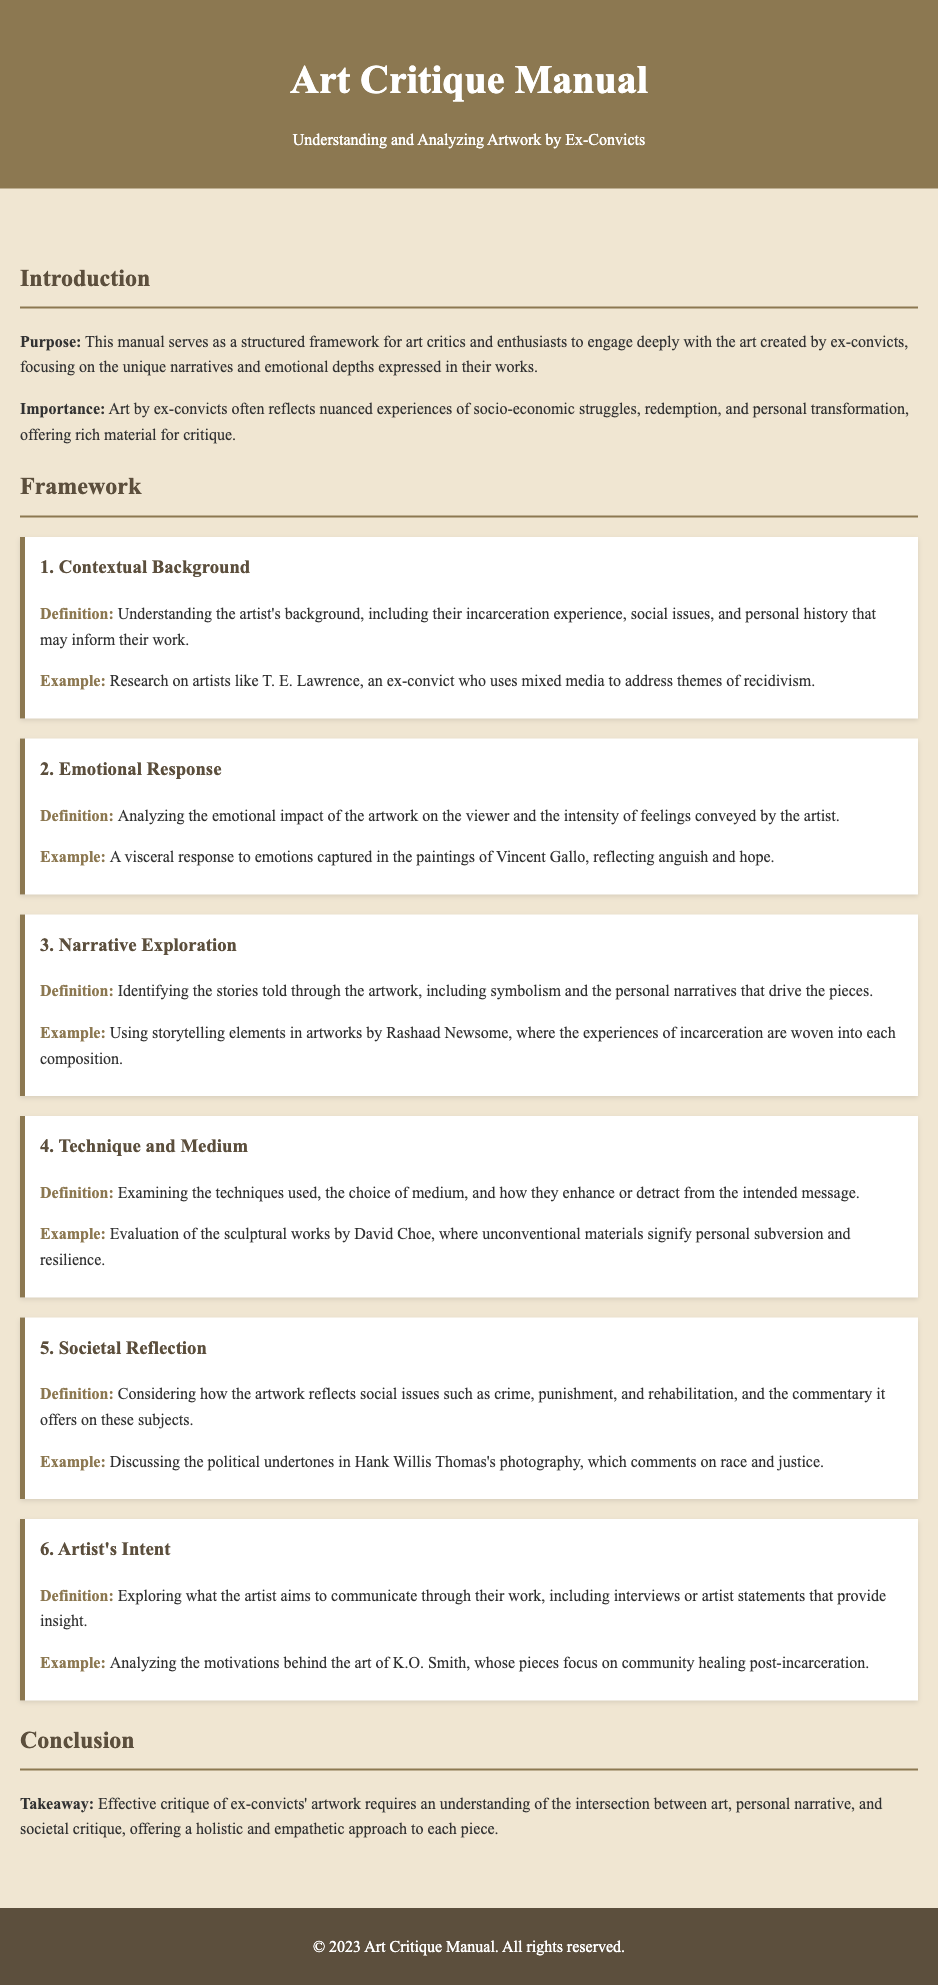What is the title of the manual? The title of the manual is stated clearly at the top of the document.
Answer: Art Critique Manual: Understanding and Analyzing Artwork by Ex-Convicts How many framework items are there? The number of framework items can be counted in the framework section of the document.
Answer: Six Who is an example artist mentioned in the first framework item? The first framework item provides an example of an artist relevant to its definition.
Answer: T. E. Lawrence What is the focus of the "Emotional Response" framework? The "Emotional Response" framework discusses the emotional impact of artwork on viewers.
Answer: Emotional impact What social issue is discussed in the "Societal Reflection" framework? The "Societal Reflection" framework considers a specific social issue related to the artwork.
Answer: Crime What does the "Artist's Intent" framework explore? The "Artist's Intent" framework explains what the artist aims to communicate through their work.
Answer: Communication What type of commentary does Hank Willis Thomas's photography offer? The framework related to societal reflection describes the nature of commentary in his work.
Answer: Political undertones What is emphasized as crucial for effective critique in the conclusion? The conclusion states a key element needed for a complete critique of artwork by ex-convicts.
Answer: Understanding the intersection 